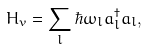<formula> <loc_0><loc_0><loc_500><loc_500>H _ { v } = \sum _ { l } \hbar { \omega _ { l } } { a ^ { \dag } _ { l } } { a _ { l } } ,</formula> 